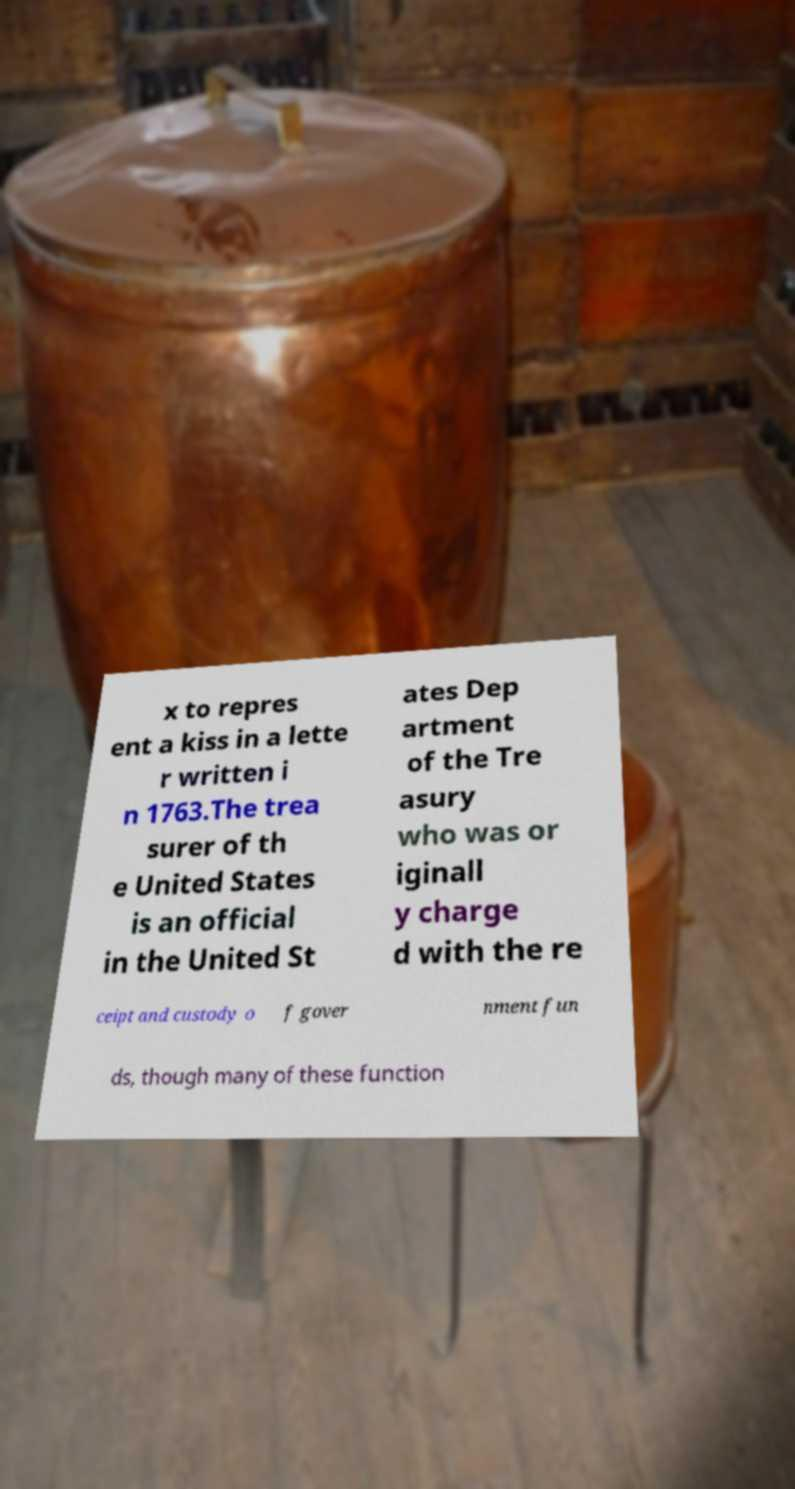Please read and relay the text visible in this image. What does it say? x to repres ent a kiss in a lette r written i n 1763.The trea surer of th e United States is an official in the United St ates Dep artment of the Tre asury who was or iginall y charge d with the re ceipt and custody o f gover nment fun ds, though many of these function 